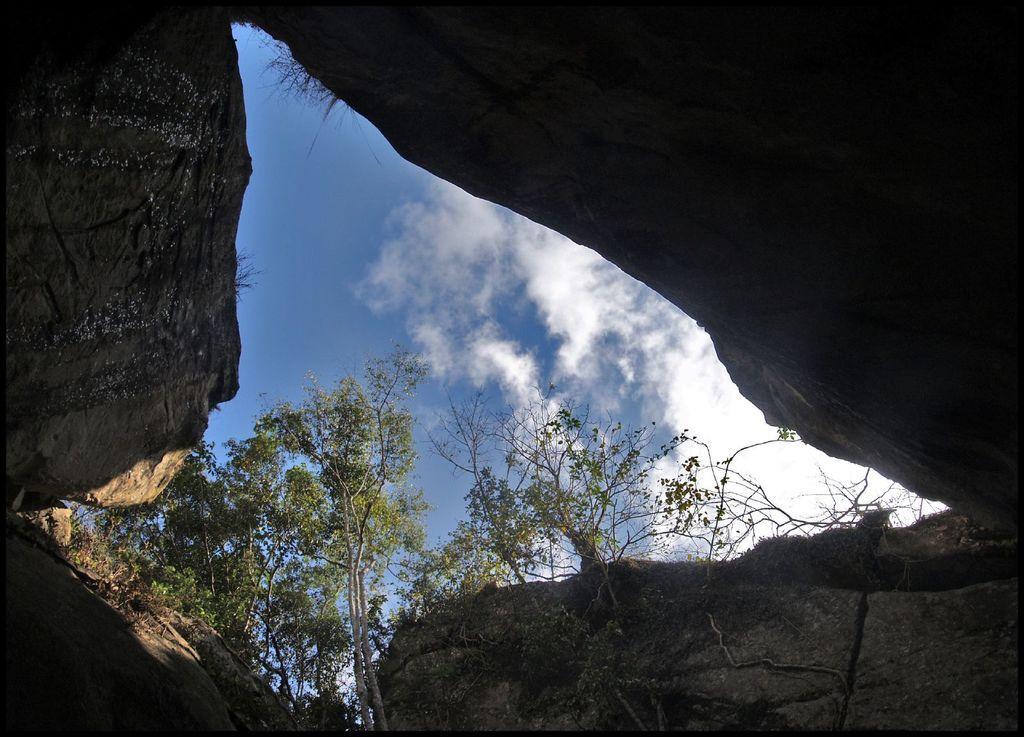What type of natural elements can be seen in the image? There are trees and rocks in the image. What is visible in the sky in the image? There are clouds in the sky in the image. What type of jelly can be seen hanging from the trees in the image? There is no jelly present in the image; it features trees and rocks. Can you describe the kiss between the rocks in the image? There are no kisses or interactions between the rocks in the image; they are simply inanimate objects. 